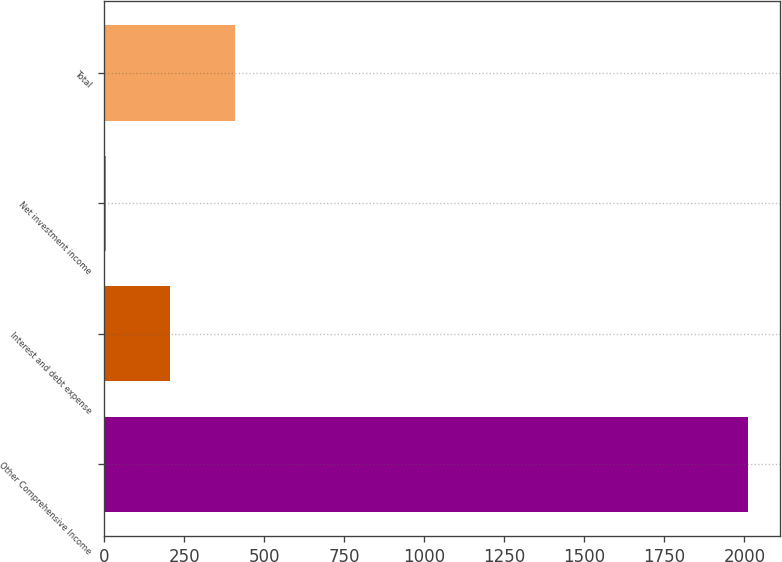Convert chart. <chart><loc_0><loc_0><loc_500><loc_500><bar_chart><fcel>Other Comprehensive Income<fcel>Interest and debt expense<fcel>Net investment income<fcel>Total<nl><fcel>2010<fcel>206.4<fcel>6<fcel>406.8<nl></chart> 